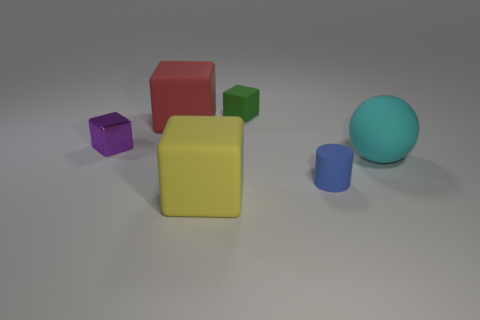Is there anything else that is the same material as the purple object?
Provide a short and direct response. No. Is the number of green matte blocks behind the big yellow thing less than the number of large matte spheres?
Keep it short and to the point. No. How many shiny things have the same color as the sphere?
Offer a terse response. 0. Are there fewer small purple shiny objects than small red metallic blocks?
Give a very brief answer. No. Is the large cyan object made of the same material as the small purple cube?
Your answer should be very brief. No. The tiny rubber cube that is behind the tiny rubber thing in front of the large red matte block is what color?
Make the answer very short. Green. How many other things are there of the same shape as the big cyan matte thing?
Make the answer very short. 0. Are there any small blue things made of the same material as the big sphere?
Offer a terse response. Yes. There is a purple object that is the same size as the blue matte cylinder; what material is it?
Your answer should be compact. Metal. The small cube behind the tiny cube in front of the large rubber cube that is on the left side of the big yellow rubber thing is what color?
Your answer should be compact. Green. 